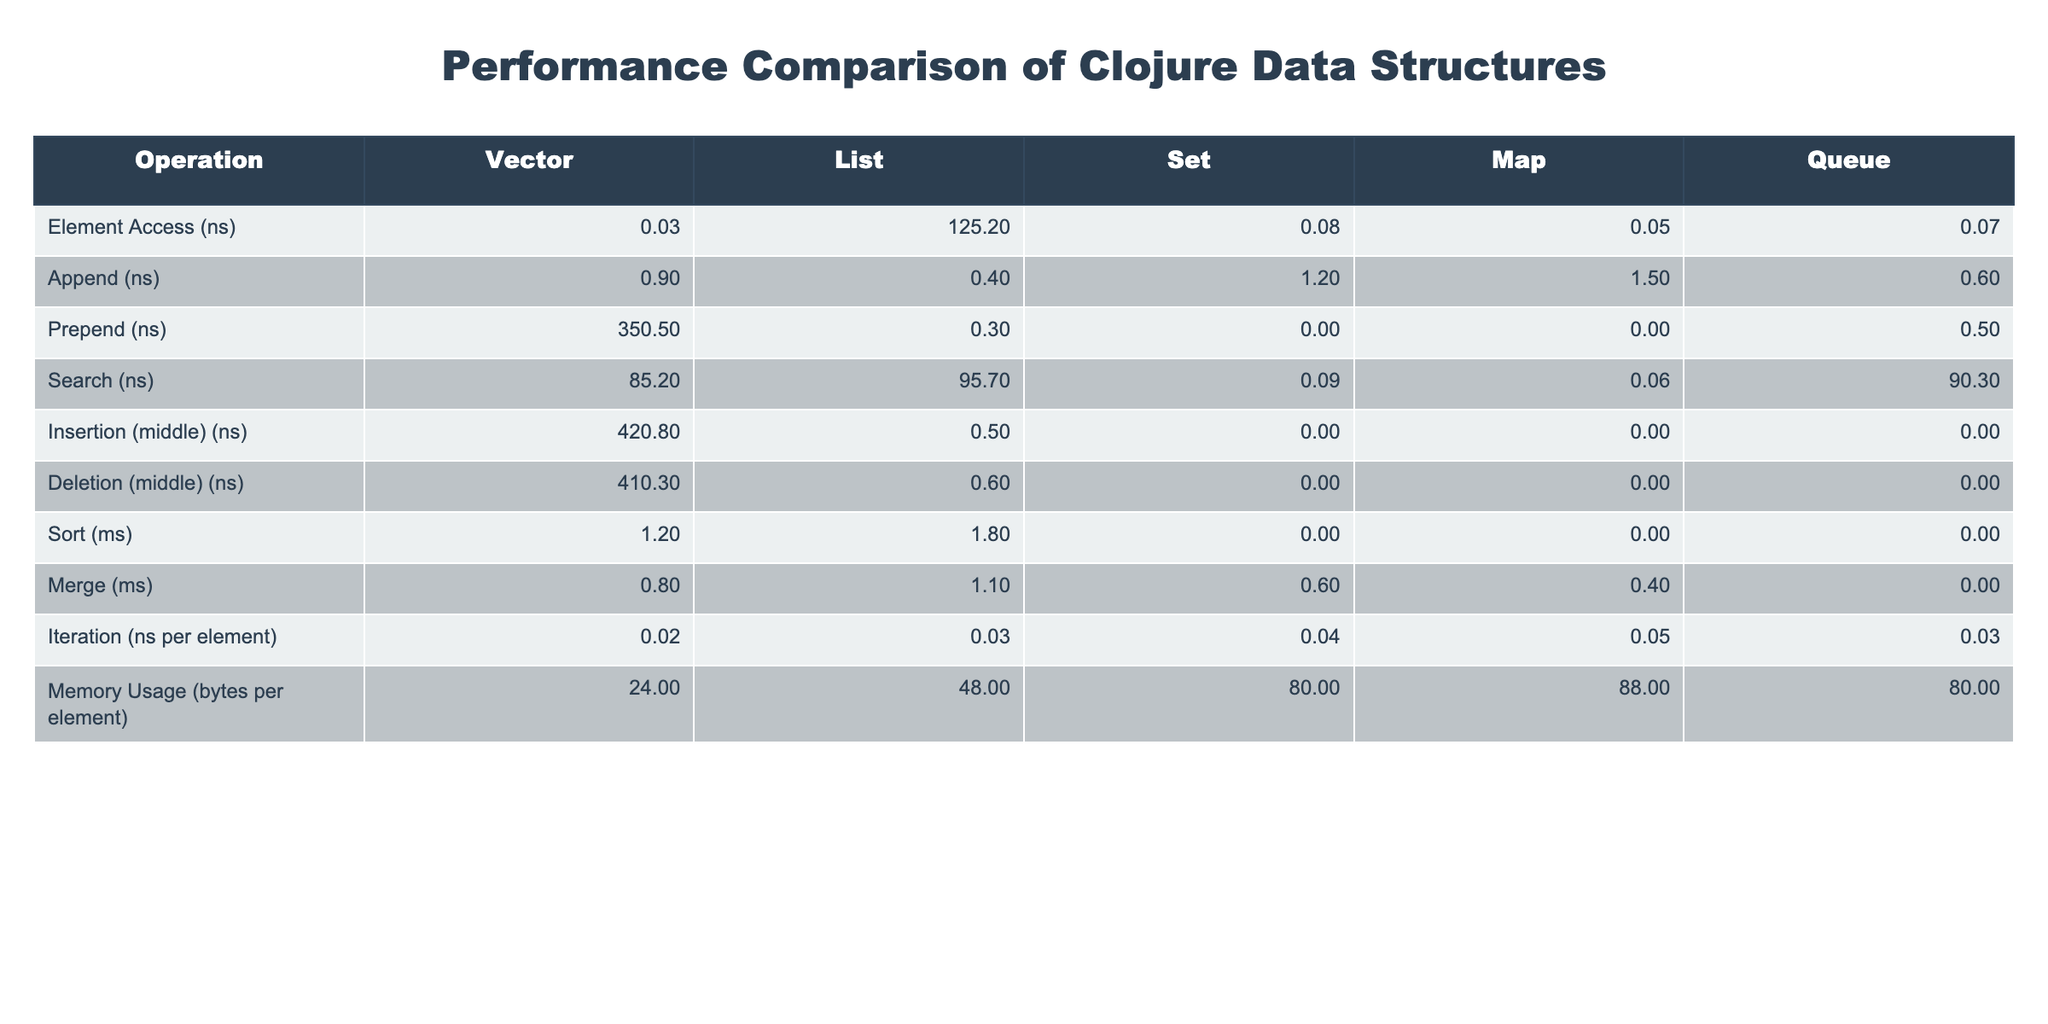What is the time taken for element access in a Vector? In the table, the time taken for element access in a Vector is explicitly listed under the 'Vector' column for the 'Element Access (ns)' row, which shows 0.03 nanoseconds.
Answer: 0.03 ns Which data structure has the fastest append operation? The 'Append (ns)' row shows the time taken for appending for each data structure. For this operation, the Vector takes 0.9 ns, which is lower compared to the List at 0.4 ns, indicating that the List has the fastest append operation.
Answer: List Is there a data structure where the prepend operation is not applicable? The table indicates that for Sets and Maps under the 'Prepend (ns)' row, the value is listed as N/A, showing that the prepend operation is not applicable for these structures.
Answer: Yes What is the difference in time taken for insertion in the middle between Vector and List? The 'Insertion (middle) (ns)' row shows 420.8 ns for Vector and 0.5 ns for List. To find the difference, we calculate 420.8 - 0.5 = 420.3 ns, which reveals that the Vector takes significantly longer than the List for this operation.
Answer: 420.3 ns What is the average memory usage in bytes per element for all data structures listed? To find the average memory usage, we take the values from the 'Memory Usage (bytes per element)' row: (24 + 48 + 80 + 88 + 80) / 5 = 64. The sum of the values is 320 bytes, divided by the number of data structures (5), gives an average of 64 bytes per element.
Answer: 64 bytes Which operation takes the longest time for all data structures listed? By comparing the values across the different operations in the table, we see that the 'Prepend' operation for Vector has the highest value listed at 350.5 ns, making it the longest operation time across all data structures.
Answer: Prepend (Vector) Is the average time for the search operation for Sets less than that of Maps? For the search operation, the 'Search (ns)' row shows 0.09 ns for Sets and 0.06 ns for Maps. We see that 0.09 ns (Set) is greater than 0.06 ns (Map), indicating that the average time for Sets is not less than for Maps.
Answer: No What is the total time taken for all queue operations compared to vector operations? For queues, we only have 'Append' time of 0.6 ns, while for vectors, total time is 0.03 (Element Access) + 0.9 (Append) + 350.5 (Prepend) + 85.2 (Search) + 420.8 (Insertion) + 410.3 (Deletion) + 1.2 (Sort) + 0.8 (Merge) + 0.02 (Iteration) which sums to 1,368.6 ns. Therefore, queues have considerably lower total time.
Answer: Queue operations are less 